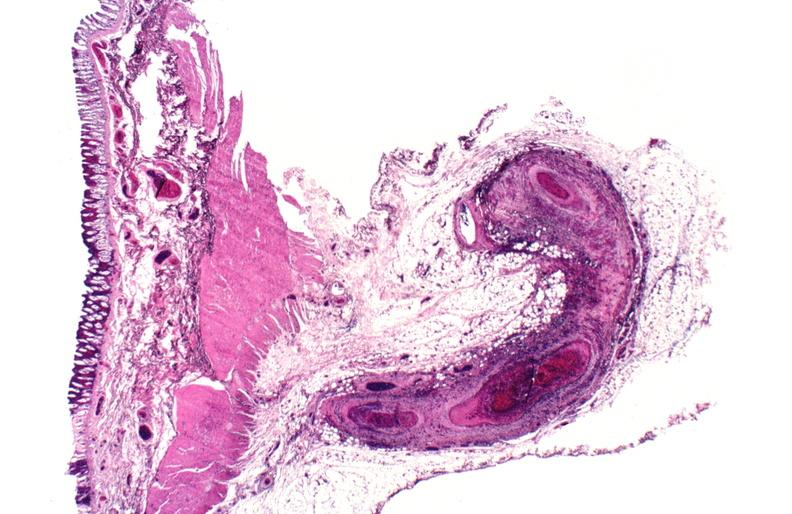where is this from?
Answer the question using a single word or phrase. Vasculature 